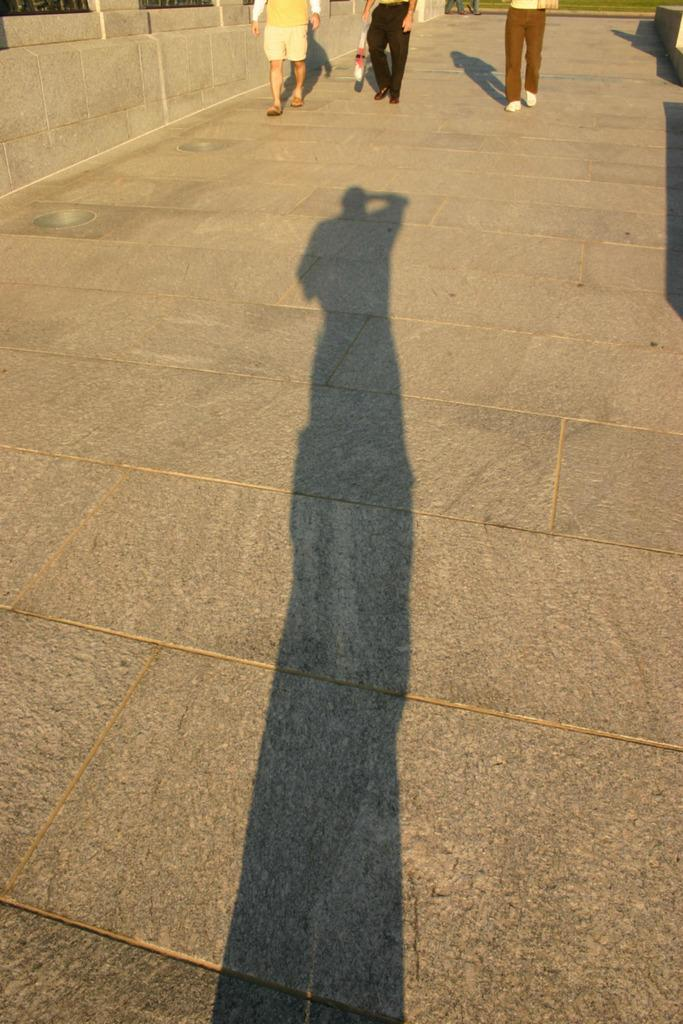How many people are walking in the foreground of the image? There are three persons walking in the foreground of the image. What surface are the persons walking on? The persons are walking on a pavement. Can you describe any additional details about the image? The shadow of a person is visible in the image. Where are the kittens playing in the image? There are no kittens present in the image. What type of picture is hanging on the wall in the image? There is no information about a picture hanging on the wall in the image. 